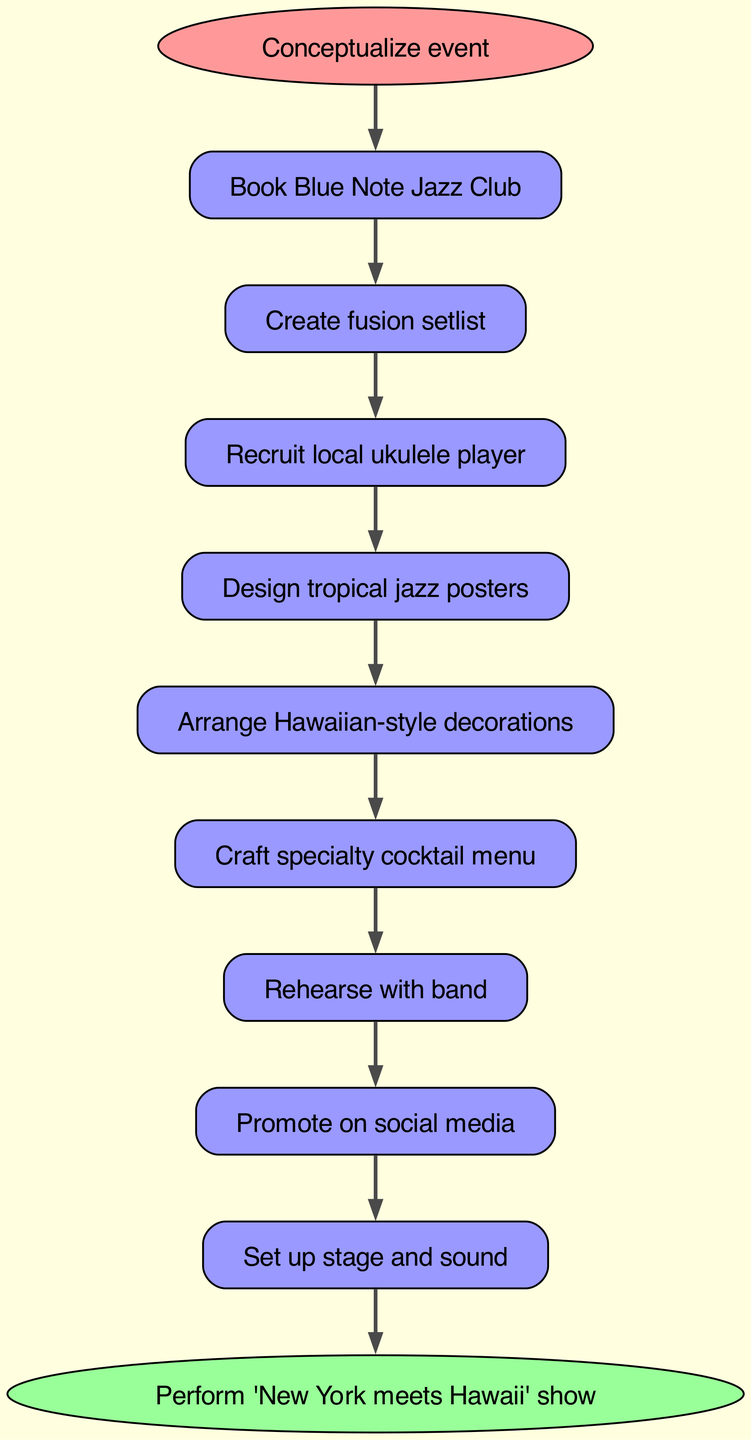What is the first step in planning the event? The first step, as indicated in the diagram, is to "Conceptualize event." This is the starting point of the flow chart, and all subsequent actions follow from this initial step.
Answer: Conceptualize event How many nodes are in the diagram? By counting the elements listed in the diagram, we find that there are a total of 10 nodes, including the start and end nodes.
Answer: 10 What follows after booking the venue? The action that follows "Book Blue Note Jazz Club" is "Create fusion setlist," as shown by the direct connection in the flow chart.
Answer: Create fusion setlist Which activity involves recruiting a musician? The activity that involves recruiting a musician is "Recruit local ukulele player." This is indicated as a step directly following the creation of the setlist in the flow chart.
Answer: Recruit local ukulele player What is the final action before the performance? The final action before the performance is "Set up stage and sound." This step leads directly to the end action of performing the show.
Answer: Set up stage and sound What is the role of social media in the event planning? Social media is used to "Promote on social media." This step appears after rehearsing with the band, showing its importance in creating awareness for the event.
Answer: Promote on social media How many connections are there in the flow chart? By examining the connections between nodes in the diagram, we see that there are a total of 9 connections, as each step follows sequentially to the next.
Answer: 9 What type of decorations are planned? The type of decorations planned is "Hawaiian-style decorations," emphasized as a necessary step in creating the event’s theme.
Answer: Hawaiian-style decorations What is the final output of the planning process? The final output of the planning process is to "Perform 'New York meets Hawaii' show." This is the end node and signifies the culmination of all planning efforts.
Answer: Perform 'New York meets Hawaii' show 